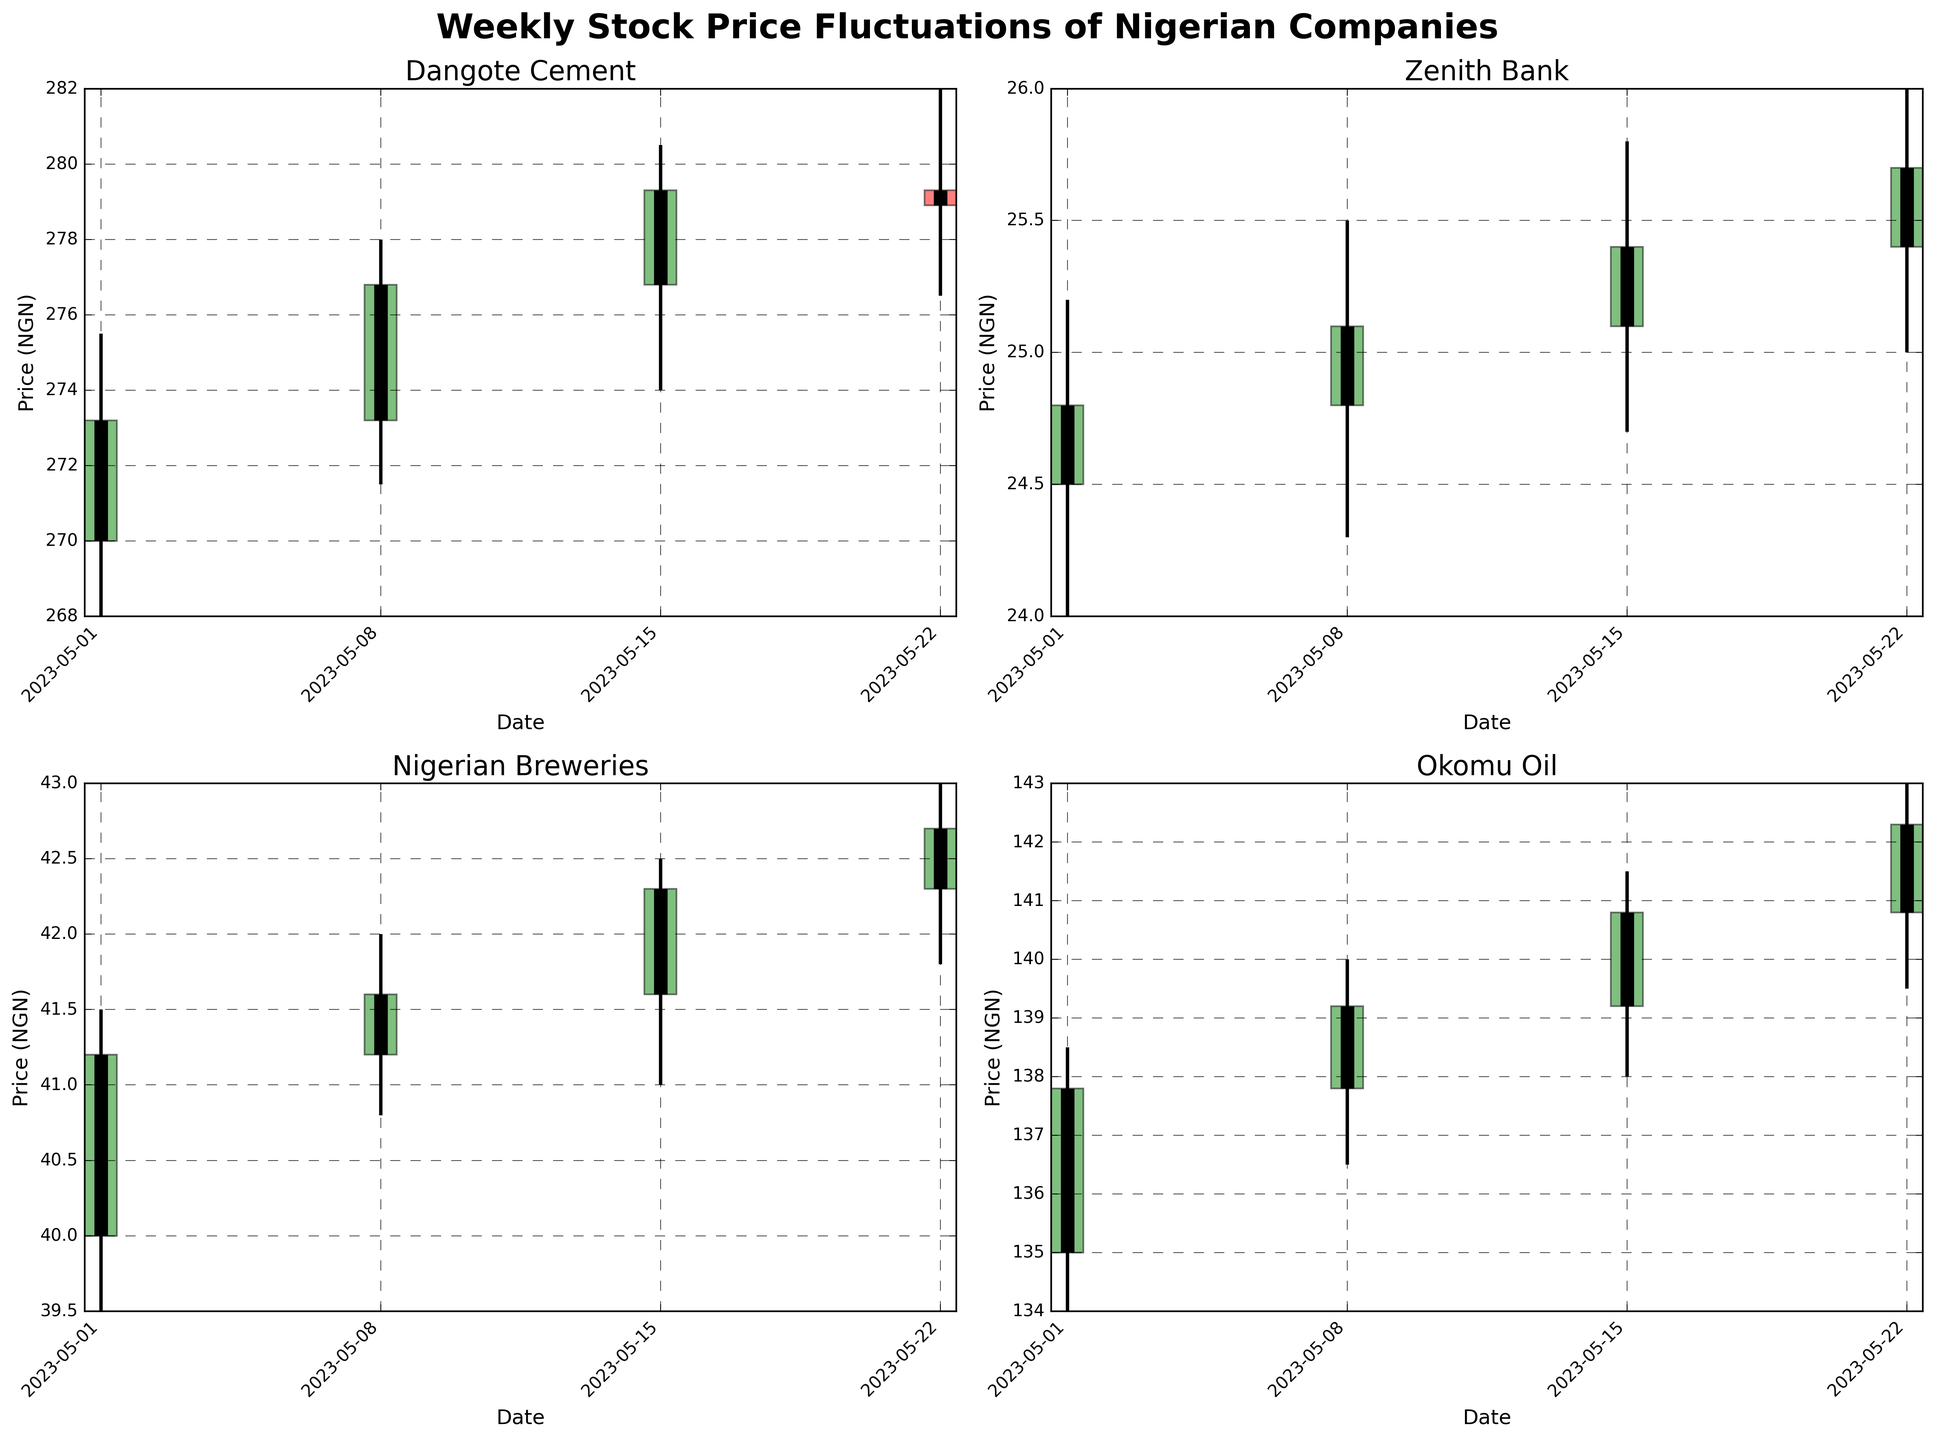What is the title of the figure? The title of the figure appears at the top, it is labeled as 'Weekly Stock Price Fluctuations of Nigerian Companies'.
Answer: Weekly Stock Price Fluctuations of Nigerian Companies Which company's stock has the highest 'High' value in the month of May 2023? By looking at the highest points reached by each company's stock over the plotted date range, Dangote Cement reached a high of 282.00 NGN, which is the highest 'High' value among all the companies.
Answer: Dangote Cement During the week of May 15, 2023, which company had the smallest difference between their 'High' and 'Low' values? For the week of May 15, 2023, the differences are calculated as follows:
- Dangote Cement: 280.50 - 274.00 = 6.50
- Zenith Bank: 25.80 - 24.70 = 1.10
- Nigerian Breweries: 42.50 - 41.00 = 1.50
- Okomu Oil: 141.50 - 138.00 = 3.50
Zenith Bank has the smallest difference, which is 1.10 NGN.
Answer: Zenith Bank On which date did Nigerian Breweries have the highest closing price, and what was it? By scanning the closing prices for Nigerian Breweries, the highest closing price in May 2023 was 42.70 NGN, which occurred on May 22, 2023.
Answer: May 22, 2023, 42.70 NGN What is the average closing price of Dangote Cement for the month of May 2023? To find the average closing price:
(273.20 + 276.80 + 279.30 + 278.90)/4 = 277.55 NGN
Answer: 277.55 NGN Which company showed the lowest opening price throughout May 2023? By examining the opening prices listed for each company, the lowest is Zenith Bank with an opening price of 24.50 NGN on May 1, 2023.
Answer: Zenith Bank Comparing the weeks of May 1 and May 22, which company's stock price increased the most? To find the increase:
- Dangote Cement: 278.90 - 273.20 = 5.70 NGN
- Zenith Bank: 25.70 - 24.80 = 0.90 NGN
- Nigerian Breweries: 42.70 - 41.20 = 1.50 NGN
- Okomu Oil: 142.30 - 137.80 = 4.50 NGN
Dangote Cement showed the largest increase of 5.70 NGN.
Answer: Dangote Cement Which company had the most consistent (smallest range) closing prices throughout May 2023? Calculate the range for the closing prices of each company:
- Dangote Cement: 279.30 - 273.20 = 6.10 NGN
- Zenith Bank: 25.70 - 24.80 = 0.90 NGN
- Nigerian Breweries: 42.70 - 41.20 = 1.50 NGN
- Okomu Oil: 142.30 - 137.80 = 4.50 NGN
Zenith Bank had the smallest range of closing prices which is 0.90 NGN.
Answer: Zenith Bank During which week did Okomu Oil have its highest closing price, and what was the price? Okomu Oil had its highest closing price of 142.30 NGN during the week of May 22, 2023.
Answer: May 22, 2023, 142.30 NGN 